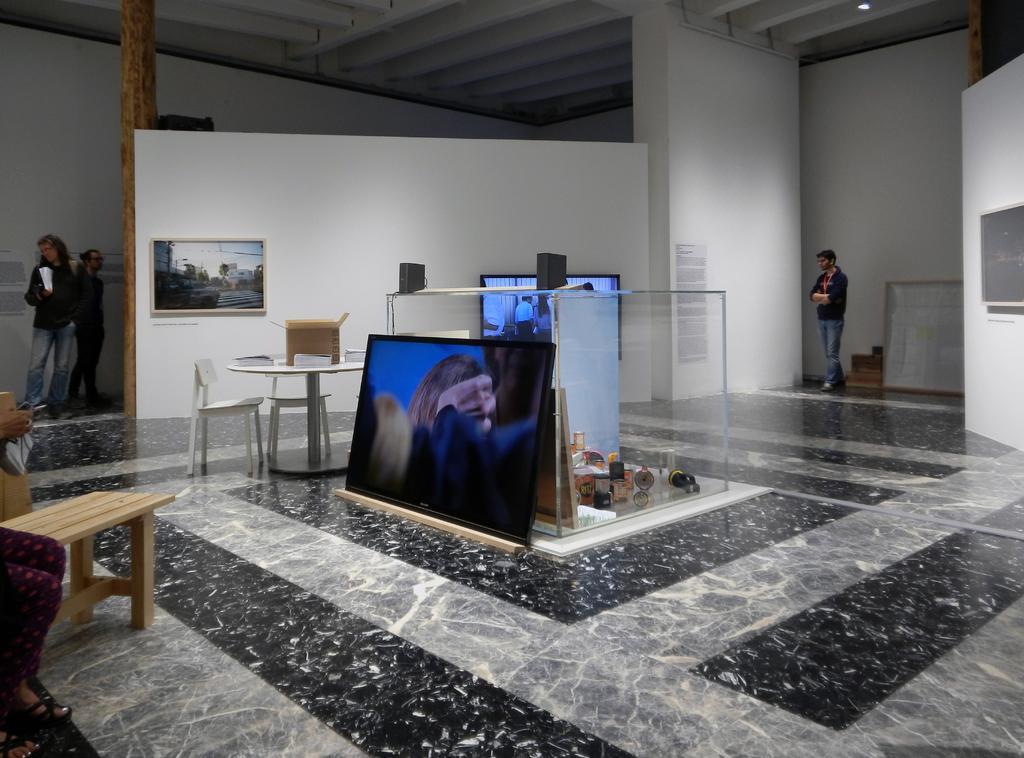Describe this image in one or two sentences. This image is clicked inside the room. There is a TV kept on the floor. In the background, there is another TV hanged on the wall. On the left, there is a frame. At the bottom, there is a floor. On the left, there is a person sitting on a bench. On the right, there is a man walking. At the top, there is a roof. 